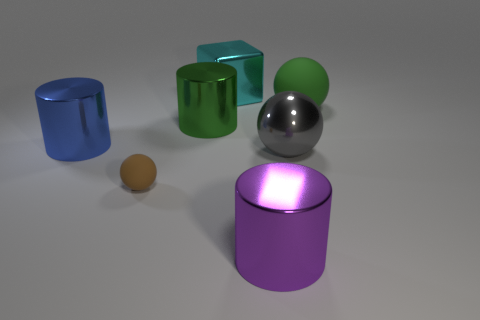Subtract all large green spheres. How many spheres are left? 2 Add 2 big objects. How many objects exist? 9 Subtract 1 blue cylinders. How many objects are left? 6 Subtract all spheres. How many objects are left? 4 Subtract 2 cylinders. How many cylinders are left? 1 Subtract all yellow spheres. Subtract all gray cubes. How many spheres are left? 3 Subtract all red cylinders. How many blue balls are left? 0 Subtract all green rubber spheres. Subtract all big gray shiny things. How many objects are left? 5 Add 6 large cyan metal objects. How many large cyan metal objects are left? 7 Add 5 large blue metal cylinders. How many large blue metal cylinders exist? 6 